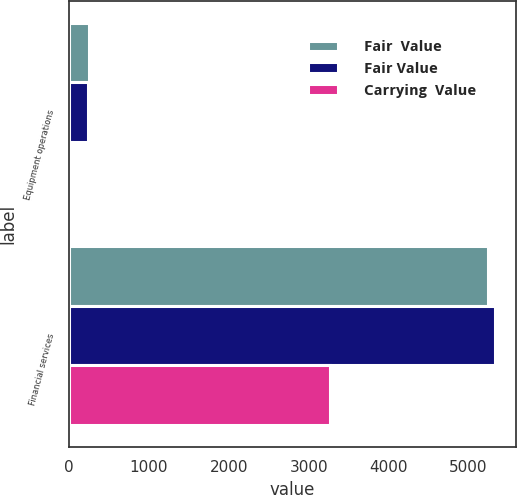Convert chart to OTSL. <chart><loc_0><loc_0><loc_500><loc_500><stacked_bar_chart><ecel><fcel>Equipment operations<fcel>Financial services<nl><fcel>Fair  Value<fcel>244<fcel>5249<nl><fcel>Fair Value<fcel>233<fcel>5331<nl><fcel>Carrying  Value<fcel>42<fcel>3267<nl></chart> 